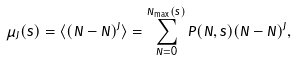<formula> <loc_0><loc_0><loc_500><loc_500>\mu _ { J } ( s ) = \langle ( N - \bar { N } ) ^ { J } \rangle = \sum _ { N = 0 } ^ { N _ { \max } ( s ) } P ( N , s ) ( N - \bar { N } ) ^ { J } ,</formula> 